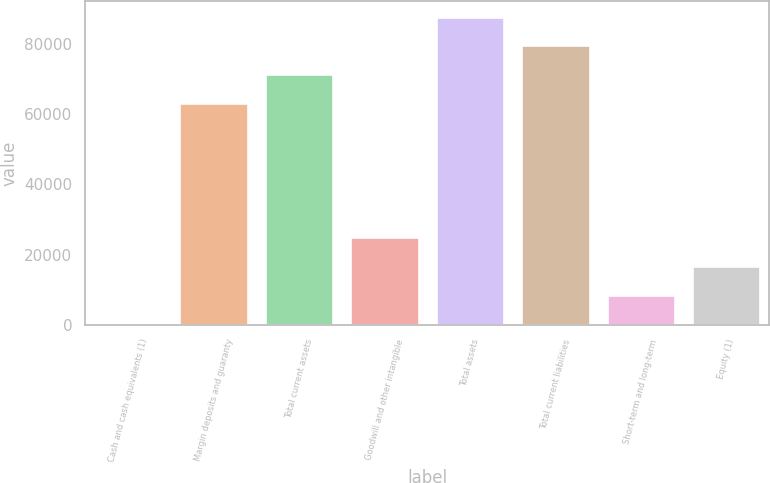<chart> <loc_0><loc_0><loc_500><loc_500><bar_chart><fcel>Cash and cash equivalents (1)<fcel>Margin deposits and guaranty<fcel>Total current assets<fcel>Goodwill and other intangible<fcel>Total assets<fcel>Total current liabilities<fcel>Short-term and long-term<fcel>Equity (1)<nl><fcel>407<fcel>63309.6<fcel>71469.2<fcel>24885.8<fcel>87788.4<fcel>79628.8<fcel>8566.6<fcel>16726.2<nl></chart> 